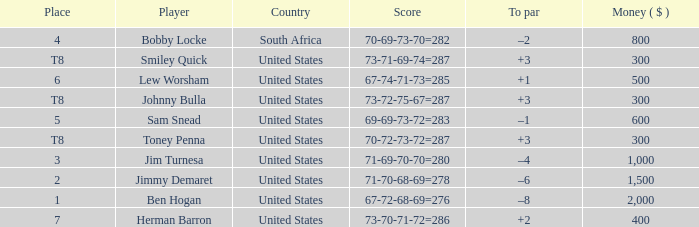What is the To par of the 4 Place Player? –2. 